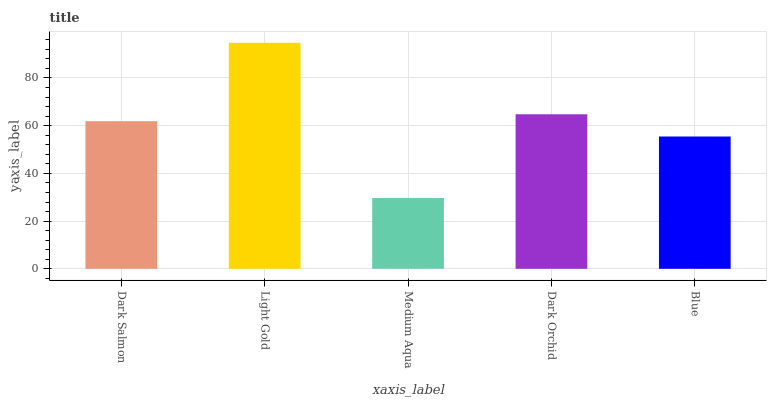Is Medium Aqua the minimum?
Answer yes or no. Yes. Is Light Gold the maximum?
Answer yes or no. Yes. Is Light Gold the minimum?
Answer yes or no. No. Is Medium Aqua the maximum?
Answer yes or no. No. Is Light Gold greater than Medium Aqua?
Answer yes or no. Yes. Is Medium Aqua less than Light Gold?
Answer yes or no. Yes. Is Medium Aqua greater than Light Gold?
Answer yes or no. No. Is Light Gold less than Medium Aqua?
Answer yes or no. No. Is Dark Salmon the high median?
Answer yes or no. Yes. Is Dark Salmon the low median?
Answer yes or no. Yes. Is Dark Orchid the high median?
Answer yes or no. No. Is Light Gold the low median?
Answer yes or no. No. 